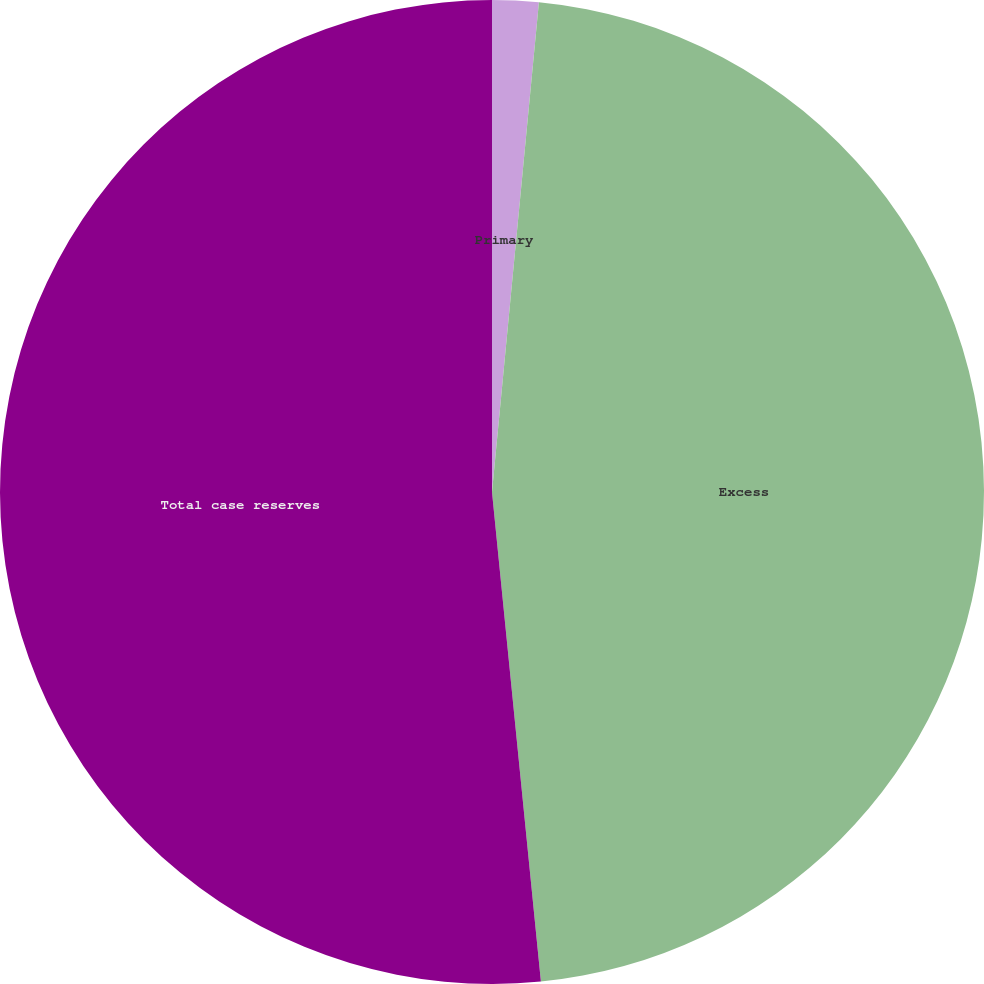<chart> <loc_0><loc_0><loc_500><loc_500><pie_chart><fcel>Primary<fcel>Excess<fcel>Total case reserves<nl><fcel>1.52%<fcel>46.89%<fcel>51.58%<nl></chart> 